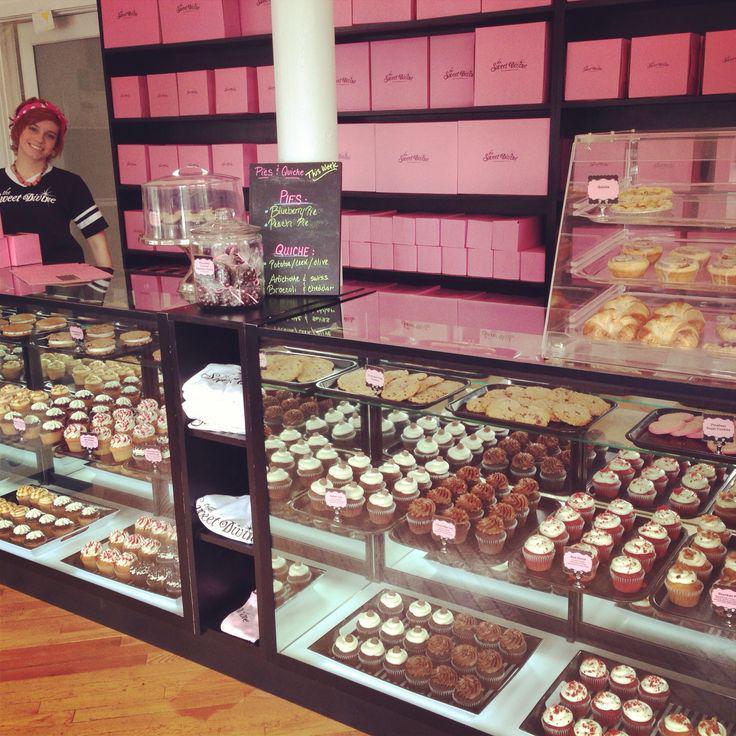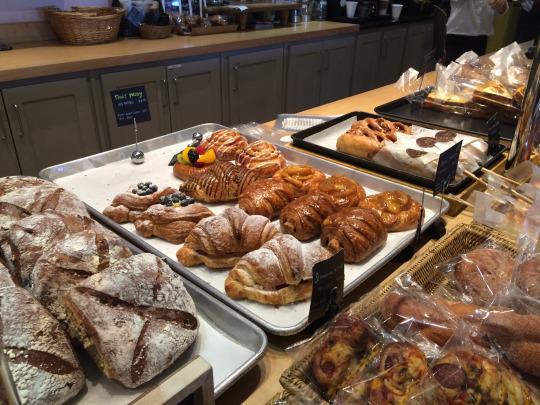The first image is the image on the left, the second image is the image on the right. Evaluate the accuracy of this statement regarding the images: "Product information is written in white on black signs in at least one image.". Is it true? Answer yes or no. No. The first image is the image on the left, the second image is the image on the right. Analyze the images presented: Is the assertion "there is a person in one of the images" valid? Answer yes or no. Yes. The first image is the image on the left, the second image is the image on the right. For the images shown, is this caption "At least one person's head can be seen in one of the images." true? Answer yes or no. Yes. 